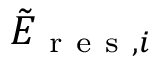Convert formula to latex. <formula><loc_0><loc_0><loc_500><loc_500>\tilde { E } _ { r e s , i }</formula> 